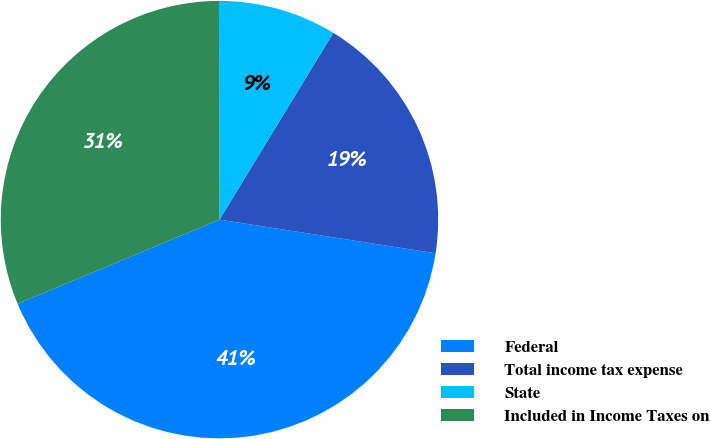Convert chart to OTSL. <chart><loc_0><loc_0><loc_500><loc_500><pie_chart><fcel>Federal<fcel>Total income tax expense<fcel>State<fcel>Included in Income Taxes on<nl><fcel>41.25%<fcel>18.75%<fcel>8.75%<fcel>31.25%<nl></chart> 